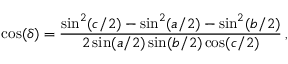<formula> <loc_0><loc_0><loc_500><loc_500>\cos ( \delta ) = \frac { \sin ^ { 2 } ( c / 2 ) - \sin ^ { 2 } ( a / 2 ) - \sin ^ { 2 } ( b / 2 ) } { 2 \sin ( a / 2 ) \sin ( b / 2 ) \cos ( c / 2 ) } \, ,</formula> 